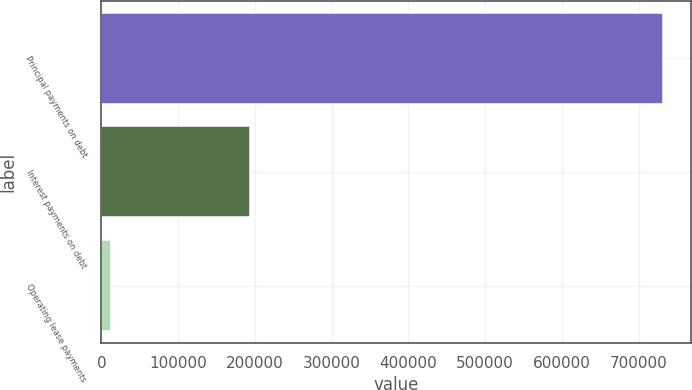<chart> <loc_0><loc_0><loc_500><loc_500><bar_chart><fcel>Principal payments on debt<fcel>Interest payments on debt<fcel>Operating lease payments<nl><fcel>732105<fcel>193255<fcel>12556<nl></chart> 